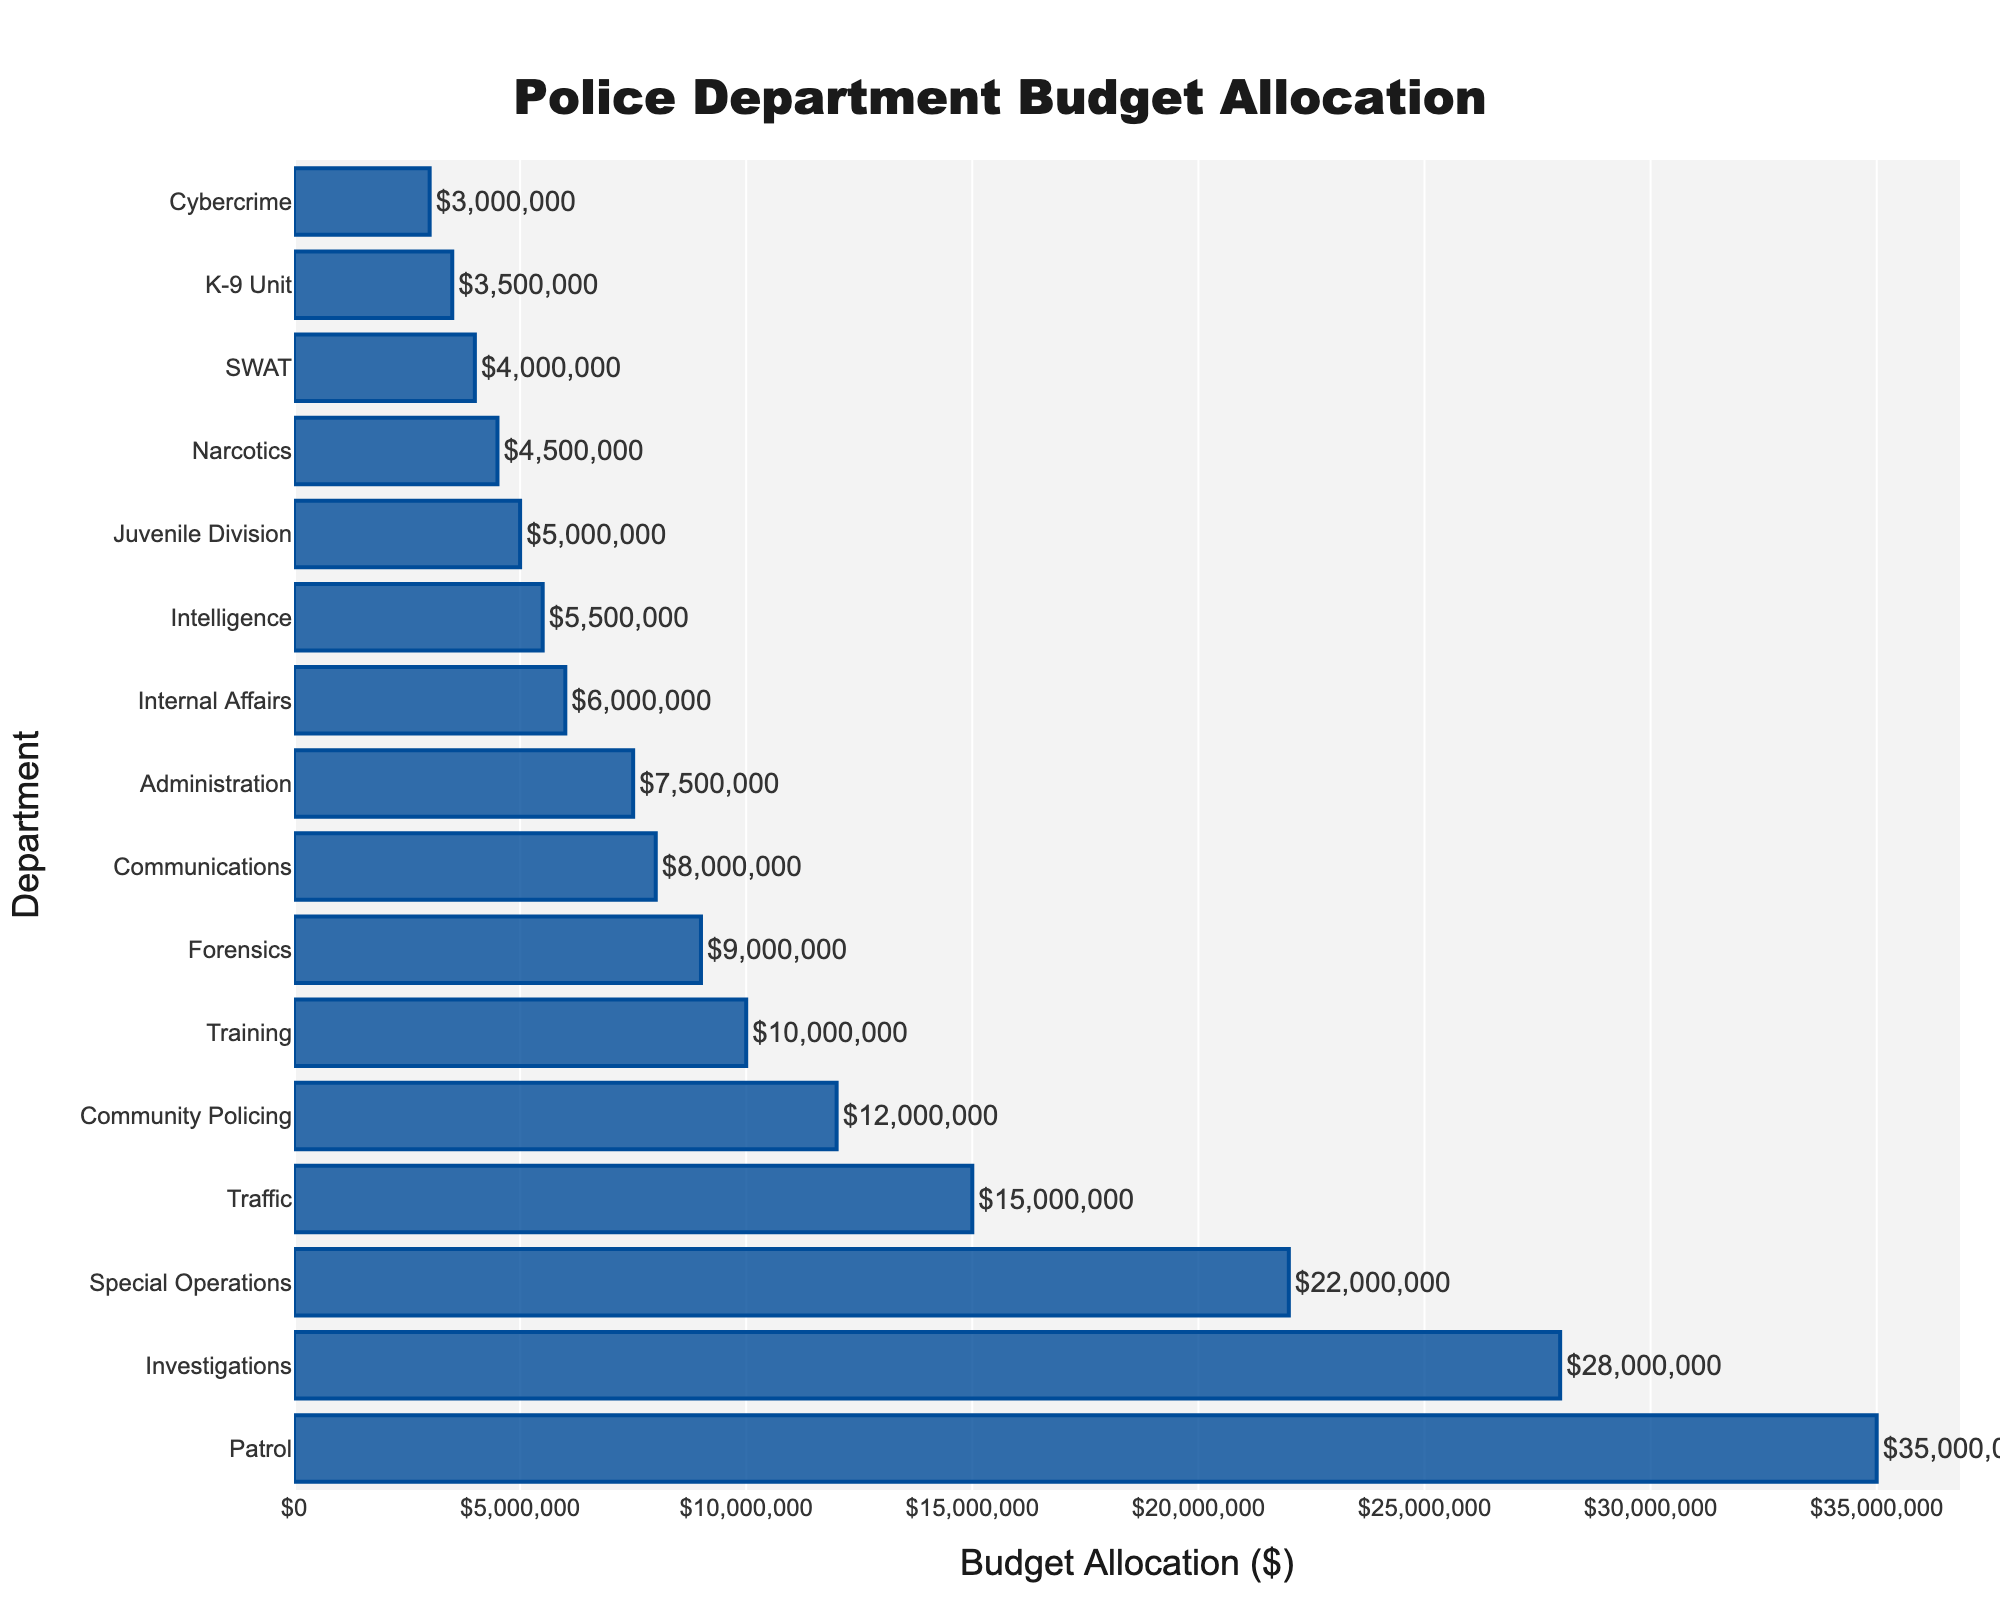What is the largest budget allocation among the police departments? The bar chart shows the budget allocations for different police departments. The longest bar represents the largest budget allocation. By looking at the chart, the Patrol department has the longest bar.
Answer: $35,000,000 Which department has the smallest budget allocation? By identifying the shortest bar in the chart, we see that the Cybercrime department has the smallest budget allocation.
Answer: $3,000,000 What is the difference in budget allocation between the Investigations and Traffic departments? The Investigations department has a budget allocation of $28,000,000 while the Traffic department has $15,000,000. Subtract the latter from the former: $28,000,000 - $15,000,000.
Answer: $13,000,000 Which department has a lower budget allocation: Forensics or Community Policing? By comparing the lengths of the bars for Forensics and Community Policing, we see that the Forensics department's bar is shorter.
Answer: Forensics What is the combined budget allocation for the SWAT and K-9 Unit departments? The budget for the SWAT department is $4,000,000 and for the K-9 Unit department is $3,500,000. Adding these together gives $4,000,000 + $3,500,000.
Answer: $7,500,000 Which three departments have the highest budget allocations? By looking at the three longest bars in the bar chart, we see that the Patrol, Investigations, and Special Operations departments have the highest budget allocations.
Answer: Patrol, Investigations, Special Operations Is there a department with a budget allocation equal to $10,000,000? By checking the bar labels and their corresponding budgets, we see that the Training department has a budget allocation of $10,000,000.
Answer: Yes, Training How much more is the Patrol department's budget compared to the Juvenile Division's budget? The Patrol department has a budget of $35,000,000, and the Juvenile Division has a budget of $5,000,000. Subtract the Juvenile Division's budget from the Patrol's: $35,000,000 - $5,000,000.
Answer: $30,000,000 What is the total budget allocation for all departments combined? Summing up all the budget allocations from the departments reveals the total budget allocation. By adding all values: $35,000,000 + $28,000,000 + $22,000,000 + $15,000,000 + $12,000,000 + $10,000,000 + $9,000,000 + $8,000,000 + $7,500,000 + $6,000,000 + $5,500,000 + $5,000,000 + $4,500,000 + $4,000,000 + $3,500,000 + $3,000,000.
Answer: $178,500,000 What would be the new budget allocation for Community Policing if it was increased by 20%? Currently, the Community Policing department has a budget of $12,000,000. A 20% increase would be calculated as $12,000,000 * 0.20 = $2,400,000. Adding this to the current budget: $12,000,000 + $2,400,000.
Answer: $14,400,000 